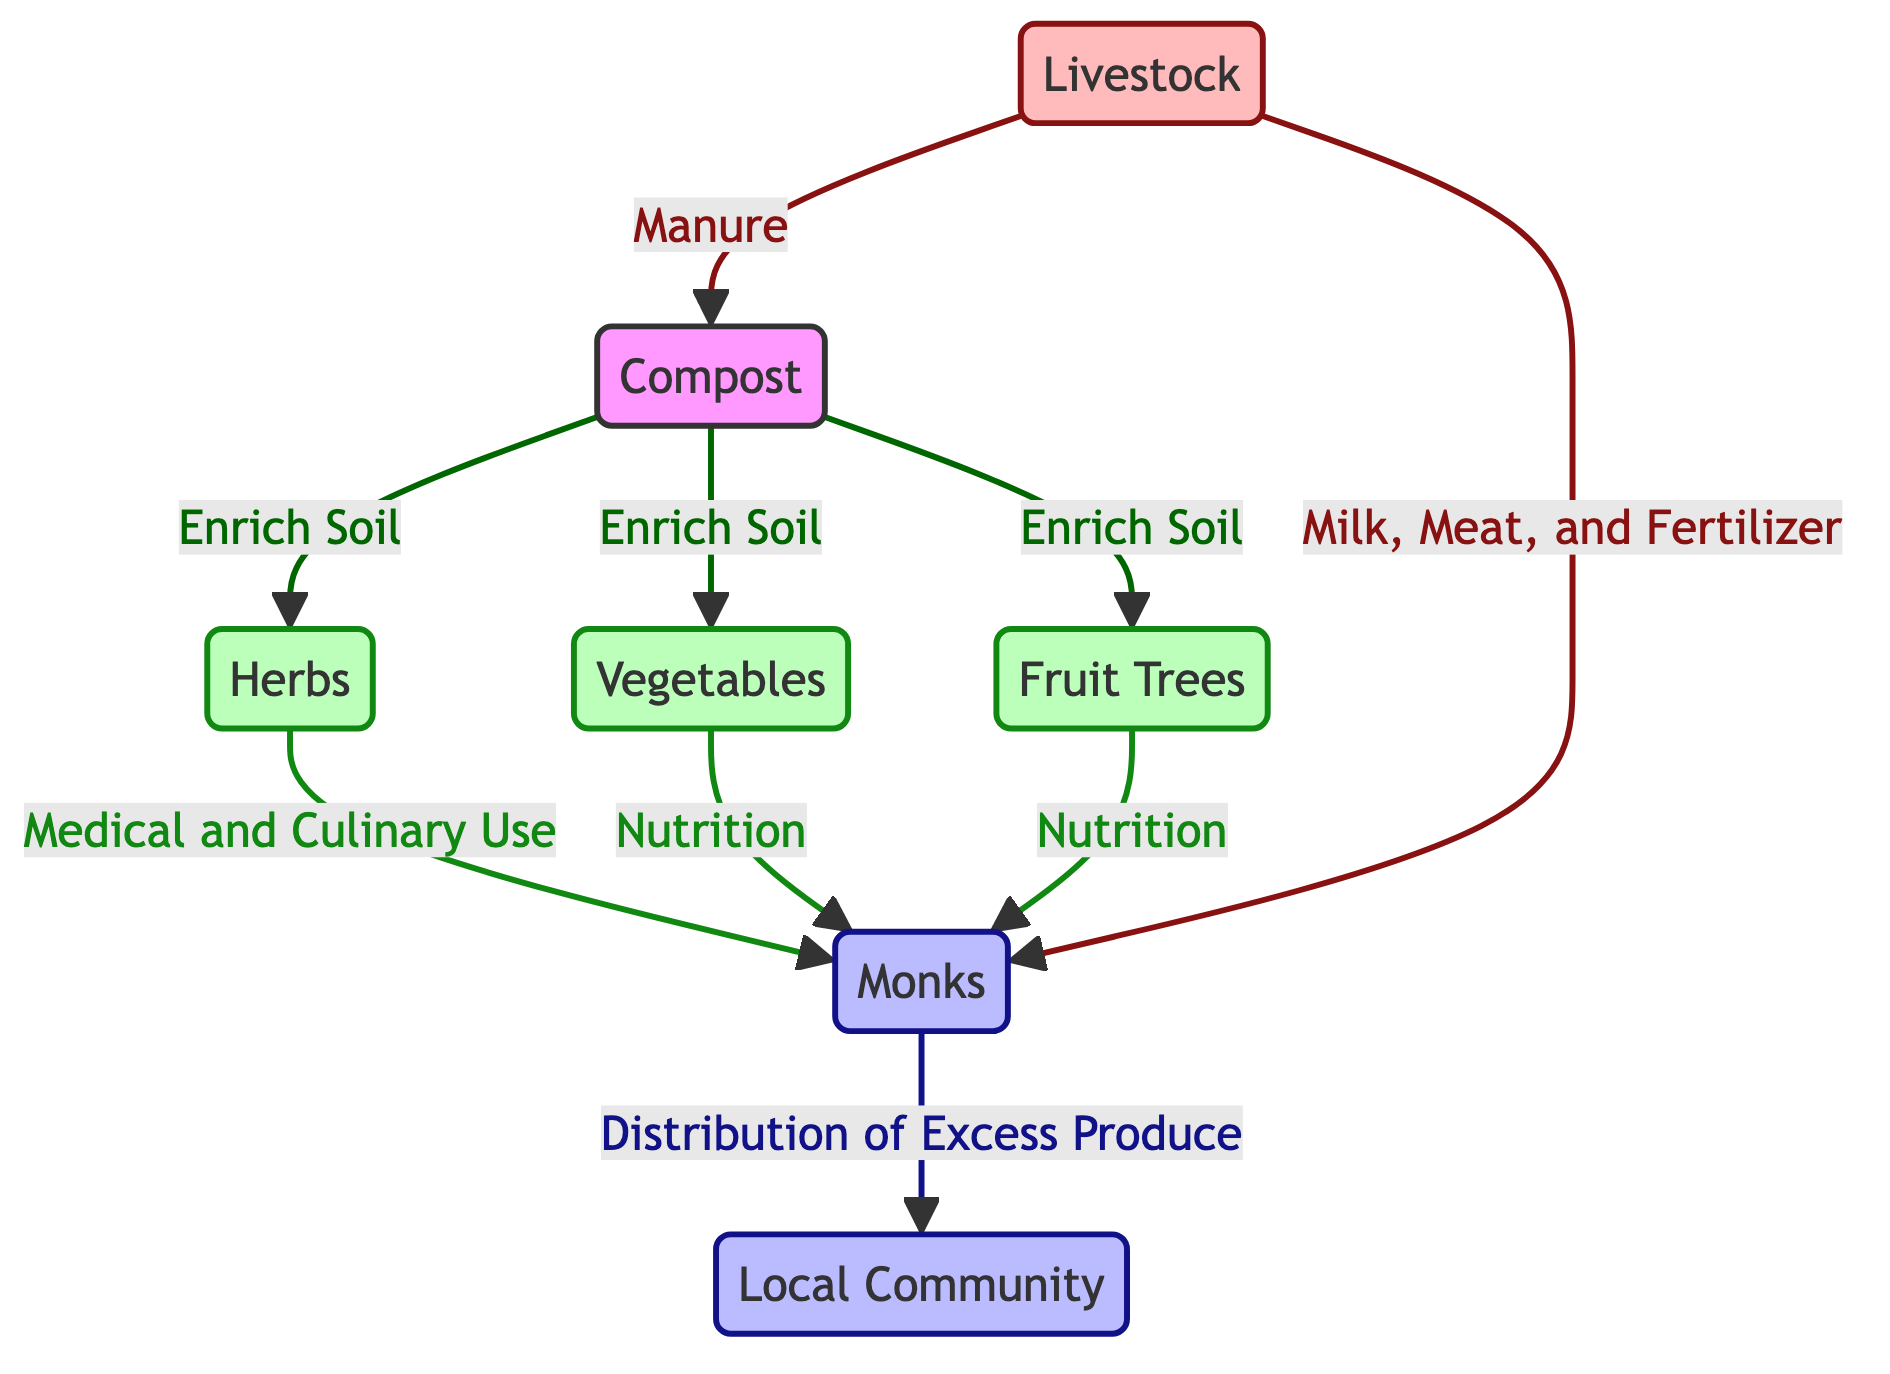What are the three types of plants featured in the diagram? The diagram includes three types of plants: herbs, vegetables, and fruit trees. This information can be identified directly from the nodes labeled in the flowchart.
Answer: herbs, vegetables, fruit trees What role do monks play in the food chain? Monks are depicted as a human node that has multiple connections in the food chain. They are responsible for using the plants for medical, culinary, and nutrition purposes, and they also distribute excess produce to the local community. This is detailed in their connecting edges that describe their activities.
Answer: Distribution of Excess Produce How many total nodes are there in the diagram? Counting the nodes in the diagram, we find there are seven distinct nodes: three for plants (herbs, vegetables, fruit trees), one for monks, one for the local community, one for livestock, and one for compost. Summing these yields a total of seven nodes.
Answer: 7 What do livestock provide to the monks? Livestock are connected to the monks through multiple edges: they provide milk, meat, and fertilizer. This connection can be traced by looking at the edges that lead from the livestock node to the monks.
Answer: Milk, Meat, and Fertilizer How does compost affect the plants in the diagram? Compost is depicted as enriching the soil for all three types of plants: herbs, vegetables, and fruit trees. This can be seen from the edges that connect compost to each of these plant nodes, showing that compost improves the growth of these plants.
Answer: Enrich Soil Which community benefits from the distribution of produce by monks? The local community is directly linked to the monks through the distribution of excess produce, as indicated by the connecting edge. Identifying this link confirms that the monks' activities support the local community.
Answer: Local Community What is the function of herbs in the food chain? Herbs serve a dual purpose in the food chain, as indicated by their connection to monks for medical and culinary use. This information is explicitly shown through the edge linking herbs to the monks with specific labels.
Answer: Medical and Culinary Use How does livestock contribute to compost in the diagram? Livestock contribute to compost by providing manure, which is explicitly noted by the edge that connects livestock to the compost node. This illustrates the role of livestock in maintaining the compost process.
Answer: Manure 